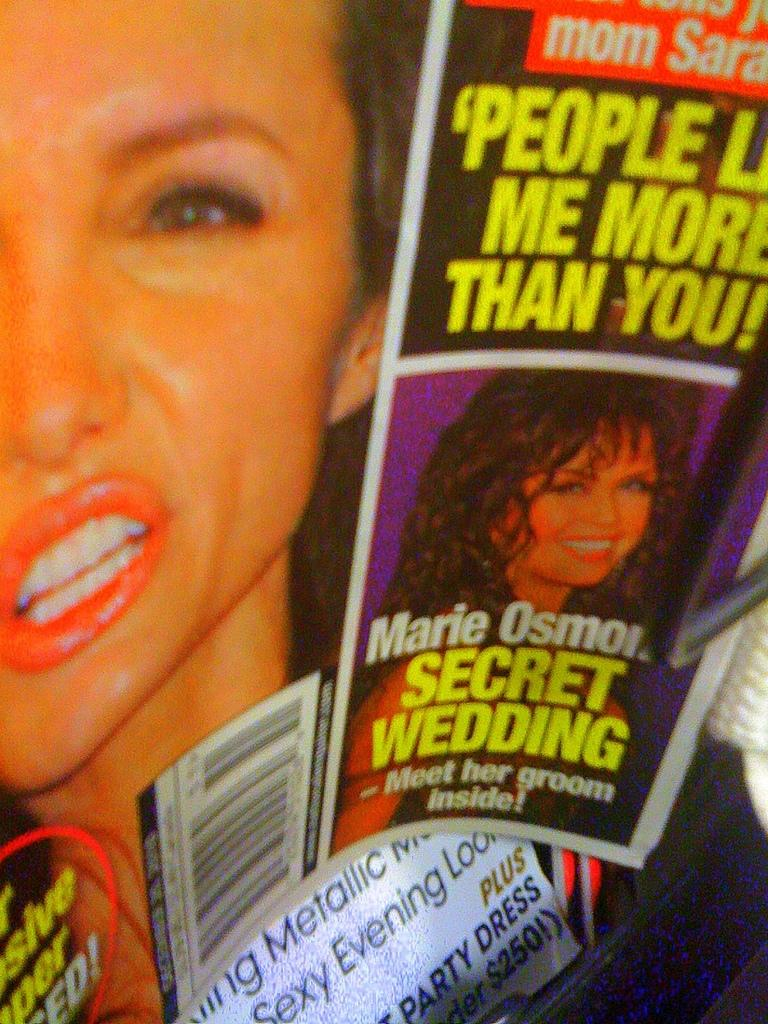Provide a one-sentence caption for the provided image. A tabloid advertises an article about Marie Osmond's "Secret wedding". 